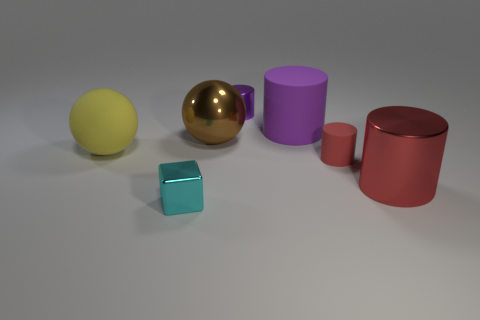There is a big metal cylinder; is it the same color as the tiny cylinder that is in front of the purple metallic object?
Provide a succinct answer. Yes. Is there a brown thing?
Your answer should be very brief. Yes. The small metallic object in front of the large metallic cylinder is what color?
Give a very brief answer. Cyan. There is a big object that is the same color as the small shiny cylinder; what material is it?
Keep it short and to the point. Rubber. Are there any large things on the left side of the yellow thing?
Offer a very short reply. No. Are there more brown spheres than big purple matte blocks?
Provide a succinct answer. Yes. What is the color of the tiny cylinder that is behind the small cylinder that is in front of the object on the left side of the small cyan block?
Make the answer very short. Purple. There is a big ball that is the same material as the small red object; what is its color?
Give a very brief answer. Yellow. What number of objects are things that are in front of the big brown metallic thing or metal cylinders in front of the metal sphere?
Keep it short and to the point. 4. There is a thing in front of the red metallic object; is its size the same as the red matte cylinder that is behind the cyan thing?
Make the answer very short. Yes. 